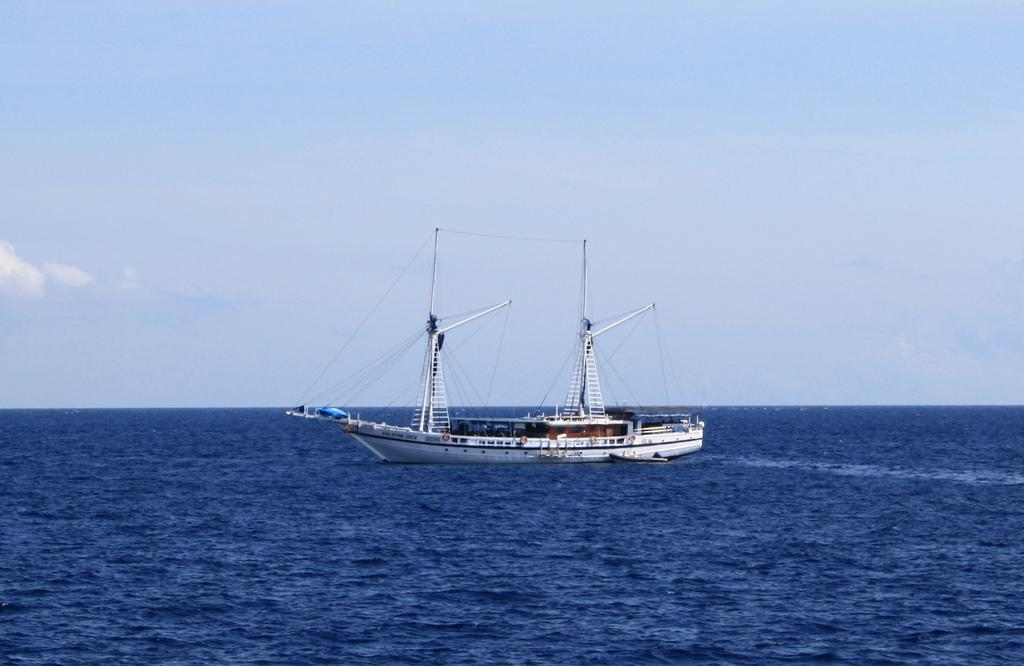What is the main subject of the image? The main subject of the image is a boat. Where is the boat located in the image? The boat is on the water in the image. What can be seen in the sky in the image? The sky is visible in the image. What type of body is visible in the image? There is no body visible in the image; it features a boat on the water. Can you tell me how many basketballs are floating in the water near the boat? There are no basketballs present in the image. What type of writing instrument is being used by the boat in the image? There is no writing instrument, such as a quill, present in the image. 